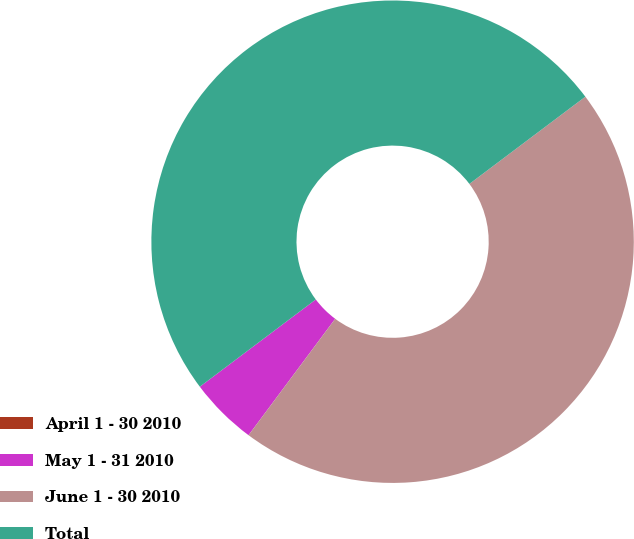Convert chart. <chart><loc_0><loc_0><loc_500><loc_500><pie_chart><fcel>April 1 - 30 2010<fcel>May 1 - 31 2010<fcel>June 1 - 30 2010<fcel>Total<nl><fcel>0.0%<fcel>4.55%<fcel>45.45%<fcel>50.0%<nl></chart> 